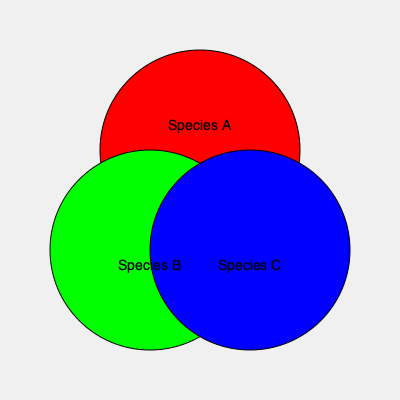In the color-coded map above, three animal species' territories are represented by overlapping circles. How many distinct areas of territory overlap can be identified, including areas where only one species is present? To determine the number of distinct areas of territory overlap, we need to analyze the intersections of the circles:

1. Areas with single species:
   - Species A (red) has an exclusive area
   - Species B (green) has an exclusive area
   - Species C (blue) has an exclusive area

2. Areas with two species overlap:
   - Species A and B overlap
   - Species B and C overlap
   - Species A and C overlap

3. Area with all three species overlap:
   - Central region where all circles intersect

To count the distinct areas:
- Single species areas: 3
- Two species overlap areas: 3
- Three species overlap area: 1

Total distinct areas = 3 + 3 + 1 = 7
Answer: 7 